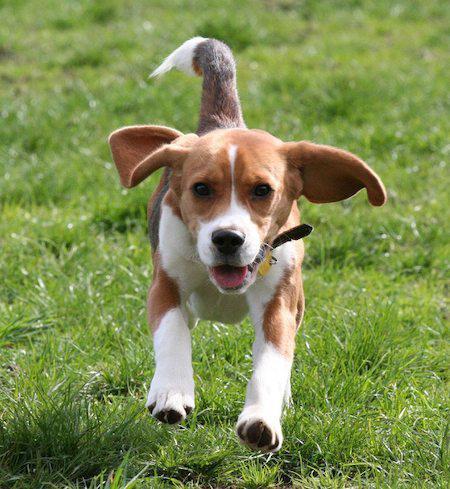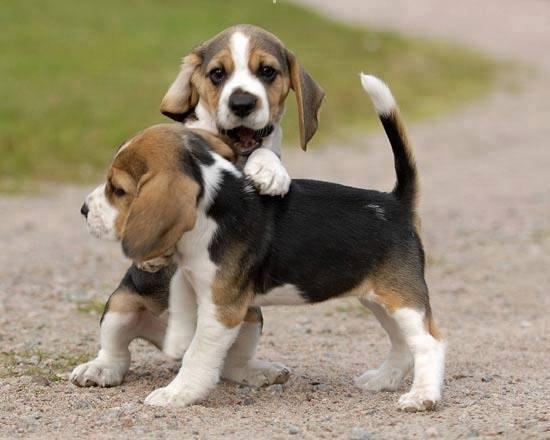The first image is the image on the left, the second image is the image on the right. Given the left and right images, does the statement "There are more dogs in the image on the right than on the left." hold true? Answer yes or no. Yes. The first image is the image on the left, the second image is the image on the right. Given the left and right images, does the statement "The right image contains at least two dogs." hold true? Answer yes or no. Yes. 